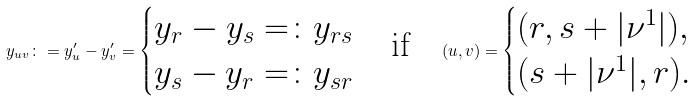<formula> <loc_0><loc_0><loc_500><loc_500>y _ { u v } \colon = y ^ { \prime } _ { u } - y ^ { \prime } _ { v } = \begin{cases} y _ { r } - y _ { s } = \colon y _ { r s } \\ y _ { s } - y _ { r } = \colon y _ { s r } \end{cases} \text {if} \quad ( u , v ) = \begin{cases} ( r , s + | \nu ^ { 1 } | ) , \\ ( s + | \nu ^ { 1 } | , r ) . \end{cases}</formula> 